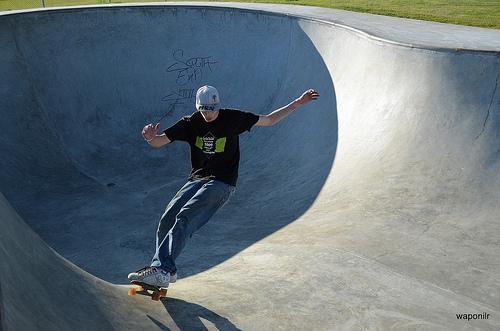How many people are in the photo?
Give a very brief answer. 1. How many wheels are touching the ground?
Give a very brief answer. 2. 